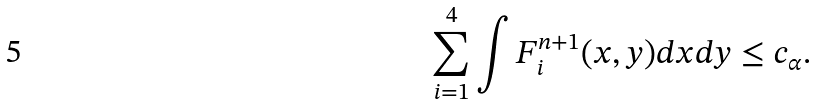Convert formula to latex. <formula><loc_0><loc_0><loc_500><loc_500>& \sum _ { i = 1 } ^ { 4 } \int F _ { i } ^ { n + 1 } ( x , y ) d x d y \leq c _ { \alpha } .</formula> 